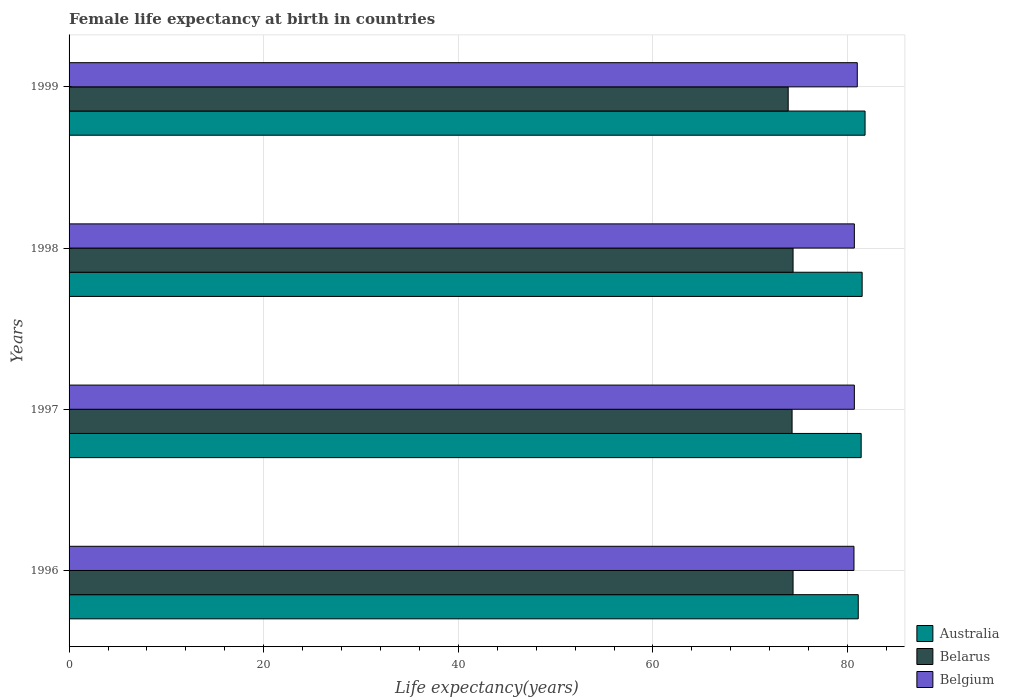Are the number of bars on each tick of the Y-axis equal?
Your answer should be very brief. Yes. How many bars are there on the 2nd tick from the top?
Keep it short and to the point. 3. How many bars are there on the 4th tick from the bottom?
Your answer should be very brief. 3. In how many cases, is the number of bars for a given year not equal to the number of legend labels?
Your answer should be very brief. 0. What is the female life expectancy at birth in Australia in 1998?
Ensure brevity in your answer.  81.5. Across all years, what is the minimum female life expectancy at birth in Australia?
Make the answer very short. 81.1. In which year was the female life expectancy at birth in Australia maximum?
Offer a terse response. 1999. What is the total female life expectancy at birth in Australia in the graph?
Your response must be concise. 325.8. What is the difference between the female life expectancy at birth in Belgium in 1997 and that in 1998?
Keep it short and to the point. 0. What is the average female life expectancy at birth in Belgium per year?
Provide a short and direct response. 80.77. In the year 1996, what is the difference between the female life expectancy at birth in Belgium and female life expectancy at birth in Belarus?
Keep it short and to the point. 6.26. What is the ratio of the female life expectancy at birth in Belgium in 1996 to that in 1998?
Your answer should be compact. 1. Is the difference between the female life expectancy at birth in Belgium in 1997 and 1998 greater than the difference between the female life expectancy at birth in Belarus in 1997 and 1998?
Offer a very short reply. Yes. What is the difference between the highest and the second highest female life expectancy at birth in Belgium?
Offer a terse response. 0.3. What is the difference between the highest and the lowest female life expectancy at birth in Australia?
Your response must be concise. 0.7. What does the 2nd bar from the bottom in 1999 represents?
Make the answer very short. Belarus. How many years are there in the graph?
Give a very brief answer. 4. What is the difference between two consecutive major ticks on the X-axis?
Ensure brevity in your answer.  20. Are the values on the major ticks of X-axis written in scientific E-notation?
Your response must be concise. No. Does the graph contain grids?
Give a very brief answer. Yes. How many legend labels are there?
Offer a terse response. 3. How are the legend labels stacked?
Keep it short and to the point. Vertical. What is the title of the graph?
Keep it short and to the point. Female life expectancy at birth in countries. Does "Ecuador" appear as one of the legend labels in the graph?
Keep it short and to the point. No. What is the label or title of the X-axis?
Provide a short and direct response. Life expectancy(years). What is the label or title of the Y-axis?
Your response must be concise. Years. What is the Life expectancy(years) in Australia in 1996?
Provide a short and direct response. 81.1. What is the Life expectancy(years) of Belarus in 1996?
Ensure brevity in your answer.  74.4. What is the Life expectancy(years) in Belgium in 1996?
Your answer should be compact. 80.66. What is the Life expectancy(years) of Australia in 1997?
Keep it short and to the point. 81.4. What is the Life expectancy(years) in Belarus in 1997?
Your answer should be very brief. 74.3. What is the Life expectancy(years) in Belgium in 1997?
Offer a very short reply. 80.7. What is the Life expectancy(years) of Australia in 1998?
Your answer should be very brief. 81.5. What is the Life expectancy(years) of Belarus in 1998?
Keep it short and to the point. 74.4. What is the Life expectancy(years) of Belgium in 1998?
Ensure brevity in your answer.  80.7. What is the Life expectancy(years) of Australia in 1999?
Your answer should be very brief. 81.8. What is the Life expectancy(years) in Belarus in 1999?
Ensure brevity in your answer.  73.9. What is the Life expectancy(years) of Belgium in 1999?
Your answer should be very brief. 81. Across all years, what is the maximum Life expectancy(years) of Australia?
Keep it short and to the point. 81.8. Across all years, what is the maximum Life expectancy(years) of Belarus?
Give a very brief answer. 74.4. Across all years, what is the maximum Life expectancy(years) of Belgium?
Give a very brief answer. 81. Across all years, what is the minimum Life expectancy(years) of Australia?
Provide a succinct answer. 81.1. Across all years, what is the minimum Life expectancy(years) in Belarus?
Offer a very short reply. 73.9. Across all years, what is the minimum Life expectancy(years) in Belgium?
Your answer should be very brief. 80.66. What is the total Life expectancy(years) in Australia in the graph?
Give a very brief answer. 325.8. What is the total Life expectancy(years) of Belarus in the graph?
Offer a very short reply. 297. What is the total Life expectancy(years) of Belgium in the graph?
Offer a very short reply. 323.06. What is the difference between the Life expectancy(years) in Australia in 1996 and that in 1997?
Your response must be concise. -0.3. What is the difference between the Life expectancy(years) of Belarus in 1996 and that in 1997?
Your response must be concise. 0.1. What is the difference between the Life expectancy(years) of Belgium in 1996 and that in 1997?
Ensure brevity in your answer.  -0.04. What is the difference between the Life expectancy(years) of Australia in 1996 and that in 1998?
Keep it short and to the point. -0.4. What is the difference between the Life expectancy(years) in Belgium in 1996 and that in 1998?
Your response must be concise. -0.04. What is the difference between the Life expectancy(years) of Australia in 1996 and that in 1999?
Give a very brief answer. -0.7. What is the difference between the Life expectancy(years) of Belarus in 1996 and that in 1999?
Your answer should be very brief. 0.5. What is the difference between the Life expectancy(years) in Belgium in 1996 and that in 1999?
Provide a short and direct response. -0.34. What is the difference between the Life expectancy(years) of Belgium in 1997 and that in 1999?
Provide a succinct answer. -0.3. What is the difference between the Life expectancy(years) of Australia in 1998 and that in 1999?
Your answer should be compact. -0.3. What is the difference between the Life expectancy(years) of Belarus in 1998 and that in 1999?
Offer a terse response. 0.5. What is the difference between the Life expectancy(years) in Belgium in 1998 and that in 1999?
Provide a succinct answer. -0.3. What is the difference between the Life expectancy(years) of Australia in 1996 and the Life expectancy(years) of Belarus in 1997?
Ensure brevity in your answer.  6.8. What is the difference between the Life expectancy(years) in Australia in 1996 and the Life expectancy(years) in Belgium in 1997?
Your answer should be very brief. 0.4. What is the difference between the Life expectancy(years) in Australia in 1996 and the Life expectancy(years) in Belgium in 1998?
Make the answer very short. 0.4. What is the difference between the Life expectancy(years) in Belarus in 1996 and the Life expectancy(years) in Belgium in 1998?
Provide a short and direct response. -6.3. What is the difference between the Life expectancy(years) of Australia in 1996 and the Life expectancy(years) of Belgium in 1999?
Provide a short and direct response. 0.1. What is the difference between the Life expectancy(years) of Belarus in 1996 and the Life expectancy(years) of Belgium in 1999?
Provide a succinct answer. -6.6. What is the difference between the Life expectancy(years) in Australia in 1997 and the Life expectancy(years) in Belarus in 1998?
Offer a very short reply. 7. What is the difference between the Life expectancy(years) in Australia in 1997 and the Life expectancy(years) in Belgium in 1998?
Offer a terse response. 0.7. What is the difference between the Life expectancy(years) of Belarus in 1997 and the Life expectancy(years) of Belgium in 1998?
Your answer should be very brief. -6.4. What is the difference between the Life expectancy(years) in Australia in 1997 and the Life expectancy(years) in Belarus in 1999?
Your answer should be very brief. 7.5. What is the difference between the Life expectancy(years) in Australia in 1997 and the Life expectancy(years) in Belgium in 1999?
Offer a terse response. 0.4. What is the difference between the Life expectancy(years) in Australia in 1998 and the Life expectancy(years) in Belarus in 1999?
Ensure brevity in your answer.  7.6. What is the difference between the Life expectancy(years) of Australia in 1998 and the Life expectancy(years) of Belgium in 1999?
Ensure brevity in your answer.  0.5. What is the difference between the Life expectancy(years) of Belarus in 1998 and the Life expectancy(years) of Belgium in 1999?
Keep it short and to the point. -6.6. What is the average Life expectancy(years) in Australia per year?
Provide a short and direct response. 81.45. What is the average Life expectancy(years) of Belarus per year?
Provide a short and direct response. 74.25. What is the average Life expectancy(years) in Belgium per year?
Your answer should be compact. 80.77. In the year 1996, what is the difference between the Life expectancy(years) of Australia and Life expectancy(years) of Belarus?
Your answer should be very brief. 6.7. In the year 1996, what is the difference between the Life expectancy(years) in Australia and Life expectancy(years) in Belgium?
Your response must be concise. 0.44. In the year 1996, what is the difference between the Life expectancy(years) of Belarus and Life expectancy(years) of Belgium?
Offer a terse response. -6.26. In the year 1997, what is the difference between the Life expectancy(years) of Australia and Life expectancy(years) of Belarus?
Provide a short and direct response. 7.1. In the year 1999, what is the difference between the Life expectancy(years) of Australia and Life expectancy(years) of Belarus?
Give a very brief answer. 7.9. In the year 1999, what is the difference between the Life expectancy(years) of Belarus and Life expectancy(years) of Belgium?
Your answer should be compact. -7.1. What is the ratio of the Life expectancy(years) of Australia in 1996 to that in 1997?
Provide a short and direct response. 1. What is the ratio of the Life expectancy(years) of Belarus in 1996 to that in 1997?
Make the answer very short. 1. What is the ratio of the Life expectancy(years) in Belgium in 1996 to that in 1997?
Make the answer very short. 1. What is the ratio of the Life expectancy(years) in Belgium in 1996 to that in 1998?
Make the answer very short. 1. What is the ratio of the Life expectancy(years) in Belarus in 1996 to that in 1999?
Your answer should be very brief. 1.01. What is the ratio of the Life expectancy(years) in Belgium in 1996 to that in 1999?
Give a very brief answer. 1. What is the ratio of the Life expectancy(years) in Belgium in 1997 to that in 1998?
Your answer should be very brief. 1. What is the ratio of the Life expectancy(years) in Australia in 1997 to that in 1999?
Give a very brief answer. 1. What is the ratio of the Life expectancy(years) of Belarus in 1997 to that in 1999?
Ensure brevity in your answer.  1.01. What is the ratio of the Life expectancy(years) of Australia in 1998 to that in 1999?
Offer a very short reply. 1. What is the ratio of the Life expectancy(years) in Belarus in 1998 to that in 1999?
Provide a succinct answer. 1.01. What is the ratio of the Life expectancy(years) of Belgium in 1998 to that in 1999?
Make the answer very short. 1. What is the difference between the highest and the second highest Life expectancy(years) in Belarus?
Offer a very short reply. 0. What is the difference between the highest and the lowest Life expectancy(years) of Australia?
Your answer should be very brief. 0.7. What is the difference between the highest and the lowest Life expectancy(years) of Belgium?
Offer a very short reply. 0.34. 